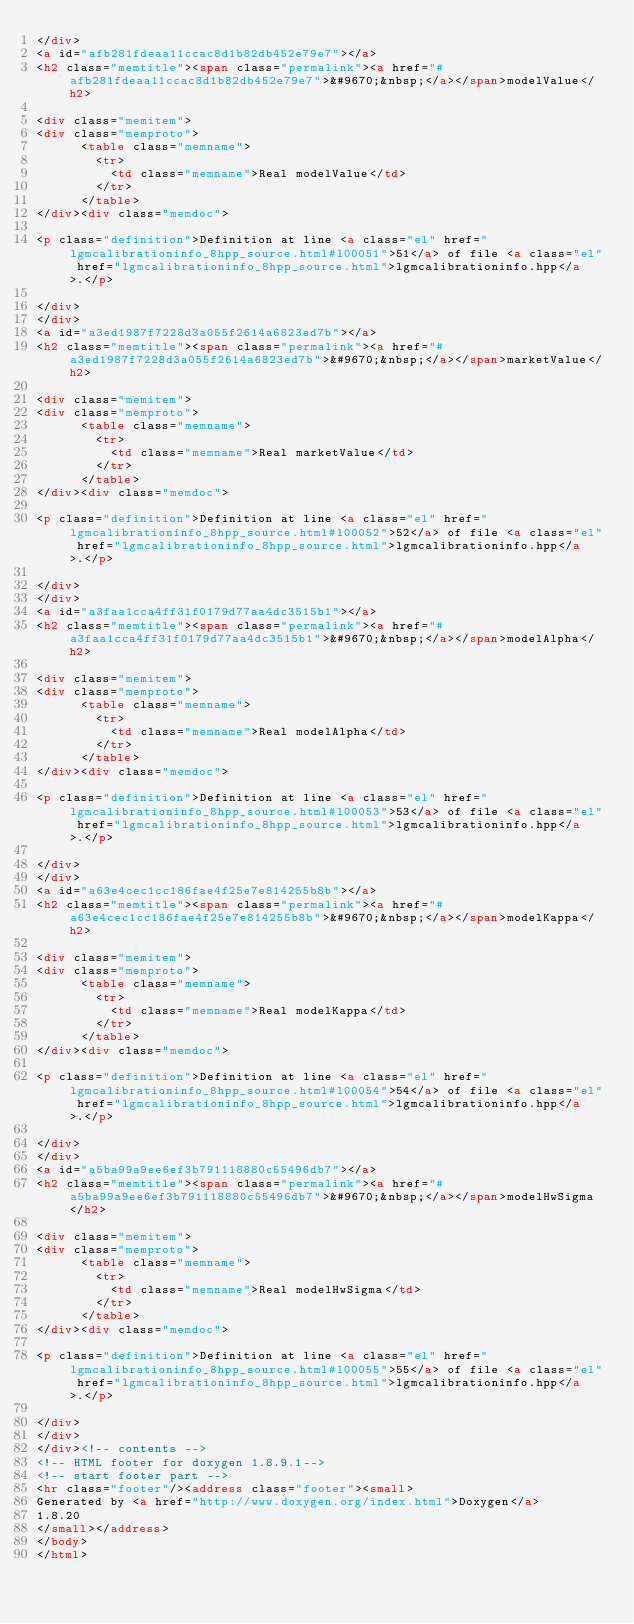Convert code to text. <code><loc_0><loc_0><loc_500><loc_500><_HTML_></div>
<a id="afb281fdeaa11ccac8d1b82db452e79e7"></a>
<h2 class="memtitle"><span class="permalink"><a href="#afb281fdeaa11ccac8d1b82db452e79e7">&#9670;&nbsp;</a></span>modelValue</h2>

<div class="memitem">
<div class="memproto">
      <table class="memname">
        <tr>
          <td class="memname">Real modelValue</td>
        </tr>
      </table>
</div><div class="memdoc">

<p class="definition">Definition at line <a class="el" href="lgmcalibrationinfo_8hpp_source.html#l00051">51</a> of file <a class="el" href="lgmcalibrationinfo_8hpp_source.html">lgmcalibrationinfo.hpp</a>.</p>

</div>
</div>
<a id="a3ed1987f7228d3a055f2614a6823ed7b"></a>
<h2 class="memtitle"><span class="permalink"><a href="#a3ed1987f7228d3a055f2614a6823ed7b">&#9670;&nbsp;</a></span>marketValue</h2>

<div class="memitem">
<div class="memproto">
      <table class="memname">
        <tr>
          <td class="memname">Real marketValue</td>
        </tr>
      </table>
</div><div class="memdoc">

<p class="definition">Definition at line <a class="el" href="lgmcalibrationinfo_8hpp_source.html#l00052">52</a> of file <a class="el" href="lgmcalibrationinfo_8hpp_source.html">lgmcalibrationinfo.hpp</a>.</p>

</div>
</div>
<a id="a3faa1cca4ff31f0179d77aa4dc3515b1"></a>
<h2 class="memtitle"><span class="permalink"><a href="#a3faa1cca4ff31f0179d77aa4dc3515b1">&#9670;&nbsp;</a></span>modelAlpha</h2>

<div class="memitem">
<div class="memproto">
      <table class="memname">
        <tr>
          <td class="memname">Real modelAlpha</td>
        </tr>
      </table>
</div><div class="memdoc">

<p class="definition">Definition at line <a class="el" href="lgmcalibrationinfo_8hpp_source.html#l00053">53</a> of file <a class="el" href="lgmcalibrationinfo_8hpp_source.html">lgmcalibrationinfo.hpp</a>.</p>

</div>
</div>
<a id="a63e4cec1cc186fae4f25e7e814255b8b"></a>
<h2 class="memtitle"><span class="permalink"><a href="#a63e4cec1cc186fae4f25e7e814255b8b">&#9670;&nbsp;</a></span>modelKappa</h2>

<div class="memitem">
<div class="memproto">
      <table class="memname">
        <tr>
          <td class="memname">Real modelKappa</td>
        </tr>
      </table>
</div><div class="memdoc">

<p class="definition">Definition at line <a class="el" href="lgmcalibrationinfo_8hpp_source.html#l00054">54</a> of file <a class="el" href="lgmcalibrationinfo_8hpp_source.html">lgmcalibrationinfo.hpp</a>.</p>

</div>
</div>
<a id="a5ba99a9ee6ef3b791118880c55496db7"></a>
<h2 class="memtitle"><span class="permalink"><a href="#a5ba99a9ee6ef3b791118880c55496db7">&#9670;&nbsp;</a></span>modelHwSigma</h2>

<div class="memitem">
<div class="memproto">
      <table class="memname">
        <tr>
          <td class="memname">Real modelHwSigma</td>
        </tr>
      </table>
</div><div class="memdoc">

<p class="definition">Definition at line <a class="el" href="lgmcalibrationinfo_8hpp_source.html#l00055">55</a> of file <a class="el" href="lgmcalibrationinfo_8hpp_source.html">lgmcalibrationinfo.hpp</a>.</p>

</div>
</div>
</div><!-- contents -->
<!-- HTML footer for doxygen 1.8.9.1-->
<!-- start footer part -->
<hr class="footer"/><address class="footer"><small>
Generated by <a href="http://www.doxygen.org/index.html">Doxygen</a>
1.8.20
</small></address>
</body>
</html>
</code> 